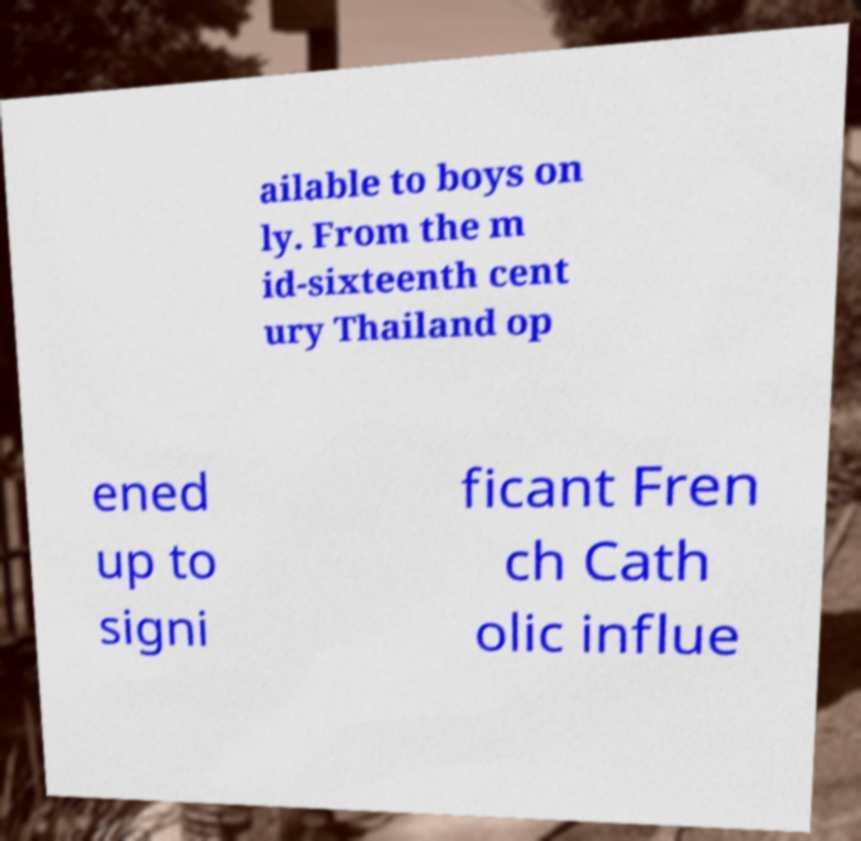For documentation purposes, I need the text within this image transcribed. Could you provide that? ailable to boys on ly. From the m id-sixteenth cent ury Thailand op ened up to signi ficant Fren ch Cath olic influe 